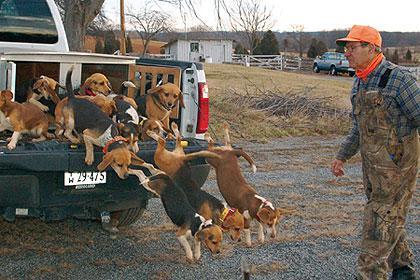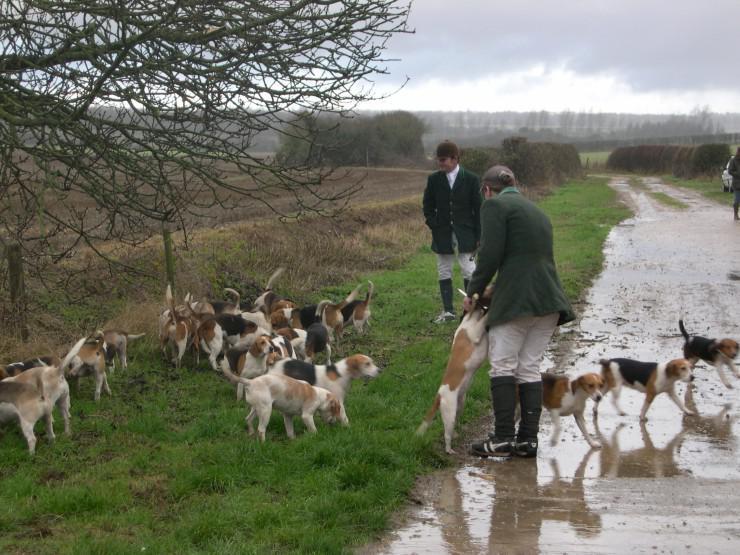The first image is the image on the left, the second image is the image on the right. Considering the images on both sides, is "There is a single vehicle shown in one of the images." valid? Answer yes or no. Yes. The first image is the image on the left, the second image is the image on the right. Evaluate the accuracy of this statement regarding the images: "Right image shows at least one man in white breeches with a pack of hounds.". Is it true? Answer yes or no. Yes. 